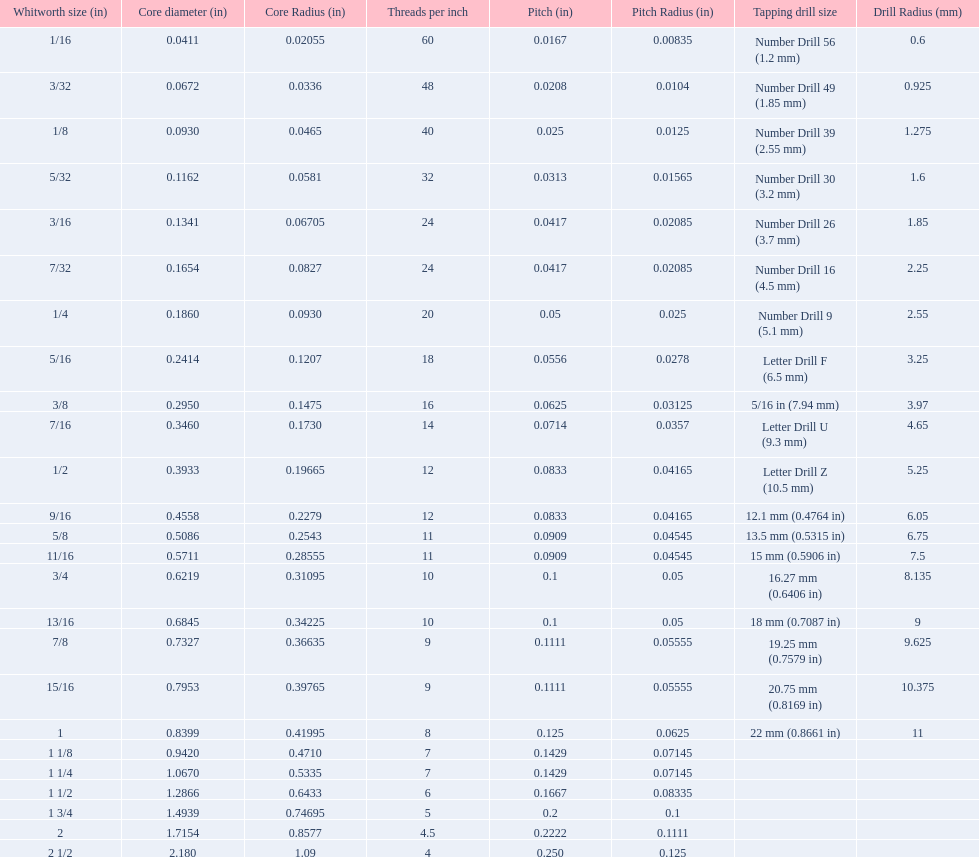What are the sizes of threads per inch? 60, 48, 40, 32, 24, 24, 20, 18, 16, 14, 12, 12, 11, 11, 10, 10, 9, 9, 8, 7, 7, 6, 5, 4.5, 4. Which whitworth size has only 5 threads per inch? 1 3/4. 